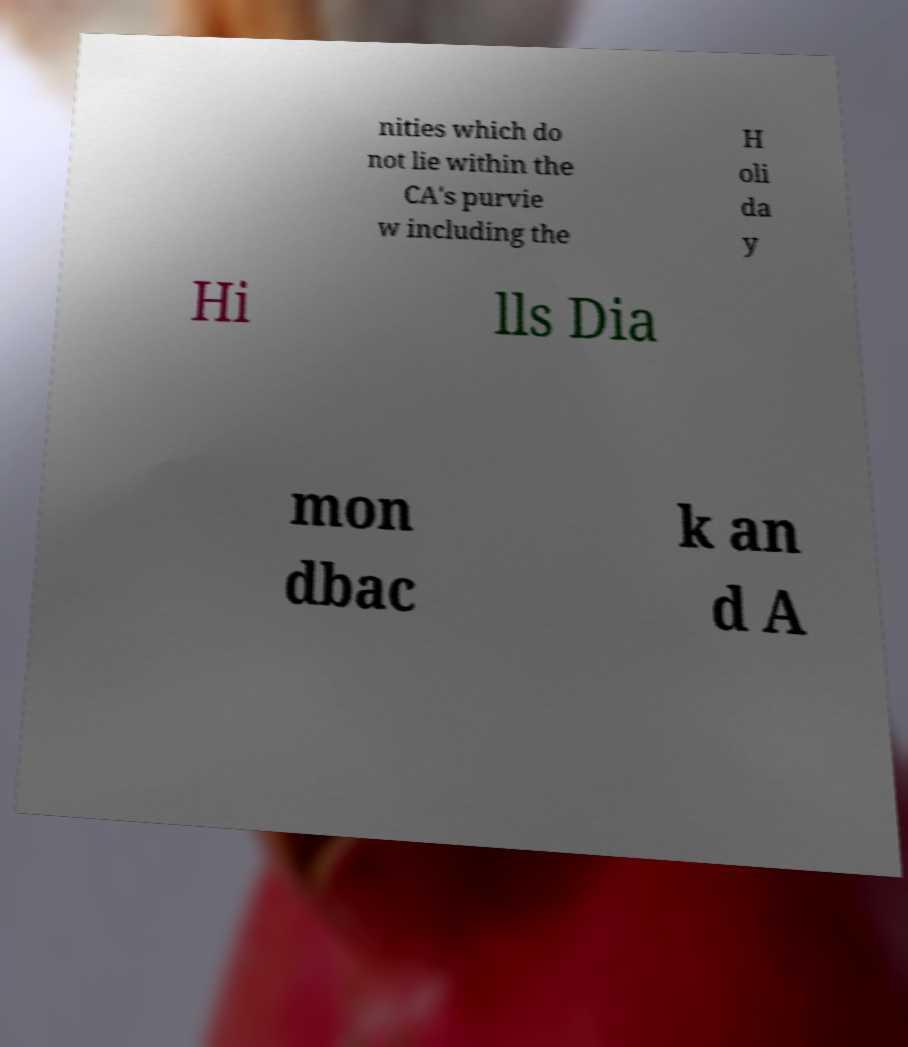Can you accurately transcribe the text from the provided image for me? nities which do not lie within the CA's purvie w including the H oli da y Hi lls Dia mon dbac k an d A 